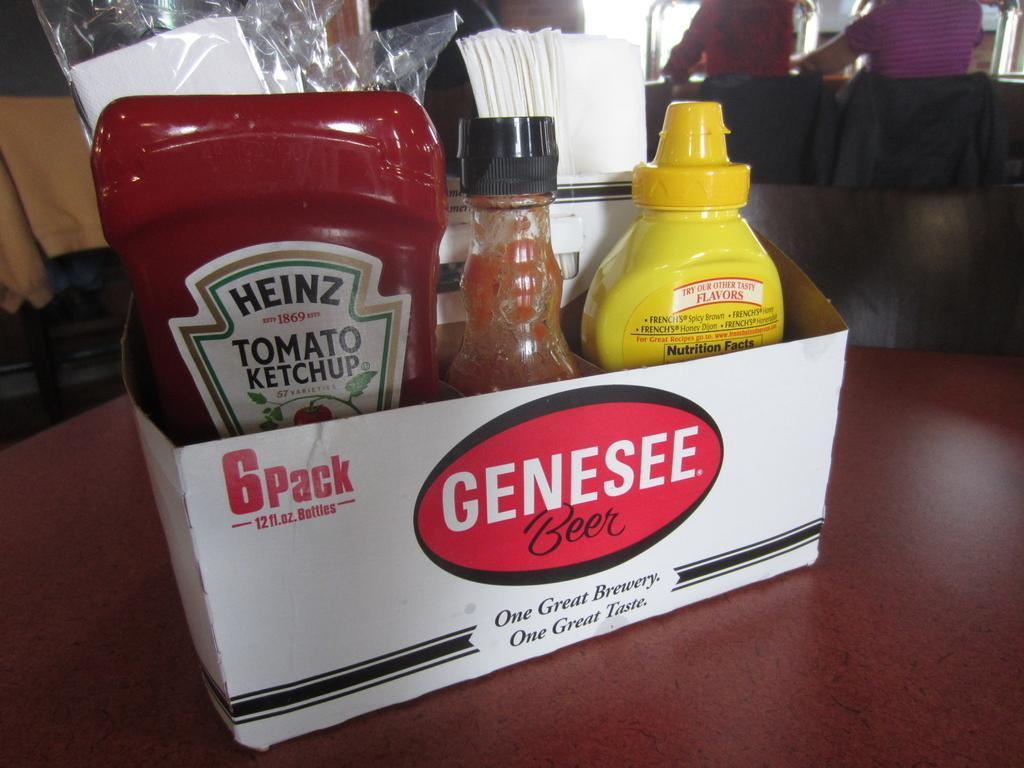<image>
Summarize the visual content of the image. Ketchup, Hot Sauce, and Mustard in a 6 park Genesee Beer package that says Our Great Brewery Our Great Taste. 